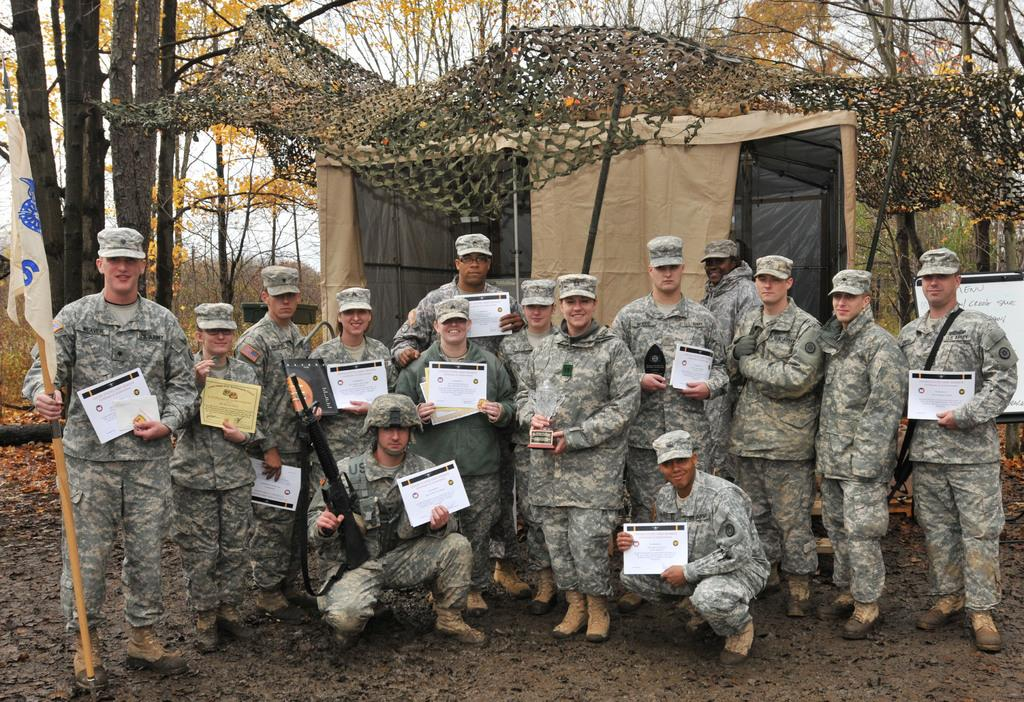How many people are in the image? There are people in the image, but the exact number is not specified. What are some people holding in the image? Some people are holding certificates in the image. What can be seen in the image besides people and certificates? There is a flag, a tent, and a net in the image. What is visible in the background of the image? Trees and the sky are visible in the background of the image. What type of juice is being served in the image? There is no juice present in the image. Who is the judge in the image? There is no judge present in the image. 